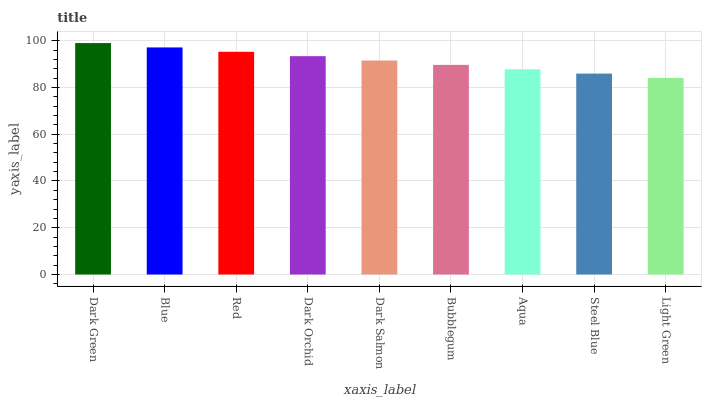Is Light Green the minimum?
Answer yes or no. Yes. Is Dark Green the maximum?
Answer yes or no. Yes. Is Blue the minimum?
Answer yes or no. No. Is Blue the maximum?
Answer yes or no. No. Is Dark Green greater than Blue?
Answer yes or no. Yes. Is Blue less than Dark Green?
Answer yes or no. Yes. Is Blue greater than Dark Green?
Answer yes or no. No. Is Dark Green less than Blue?
Answer yes or no. No. Is Dark Salmon the high median?
Answer yes or no. Yes. Is Dark Salmon the low median?
Answer yes or no. Yes. Is Dark Orchid the high median?
Answer yes or no. No. Is Steel Blue the low median?
Answer yes or no. No. 